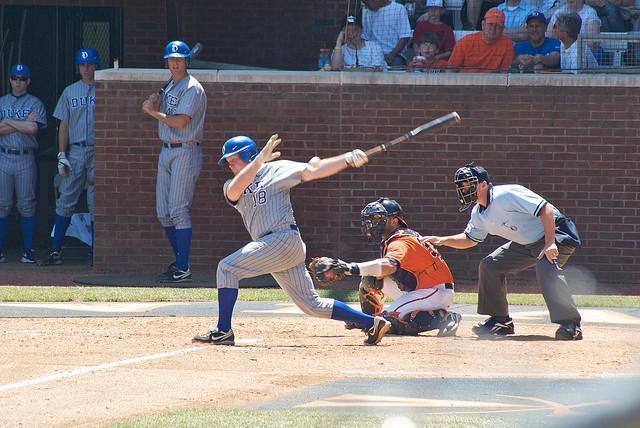What baseball player has the same first name as the name on the player all the way to the left's jersey?
Indicate the correct choice and explain in the format: 'Answer: answer
Rationale: rationale.'
Options: Duke snider, jim kaat, alabama al, stanford napoli. Answer: duke snider.
Rationale: The person who is on the left is named duke. 